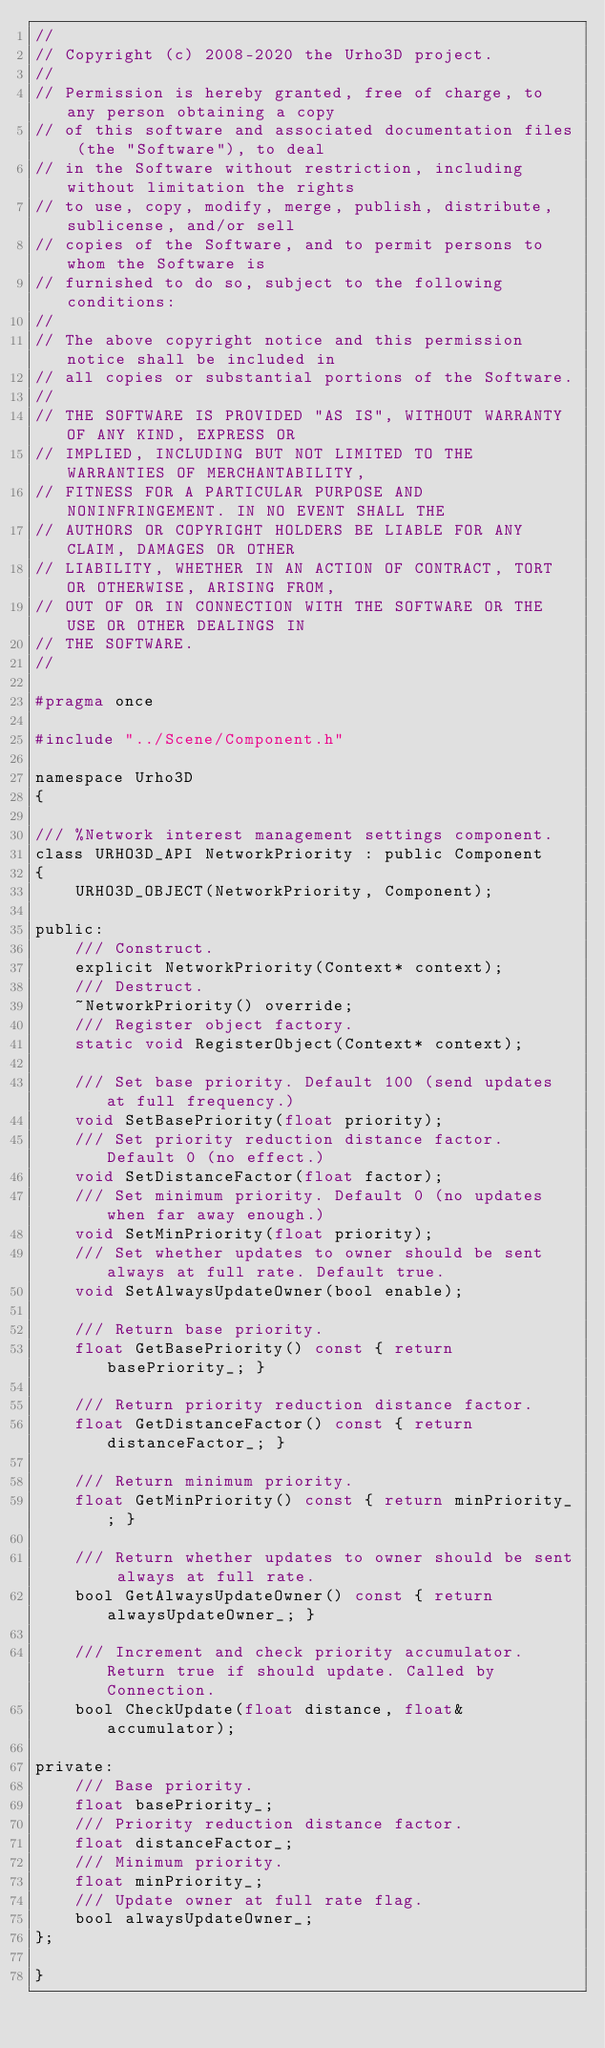<code> <loc_0><loc_0><loc_500><loc_500><_C_>//
// Copyright (c) 2008-2020 the Urho3D project.
//
// Permission is hereby granted, free of charge, to any person obtaining a copy
// of this software and associated documentation files (the "Software"), to deal
// in the Software without restriction, including without limitation the rights
// to use, copy, modify, merge, publish, distribute, sublicense, and/or sell
// copies of the Software, and to permit persons to whom the Software is
// furnished to do so, subject to the following conditions:
//
// The above copyright notice and this permission notice shall be included in
// all copies or substantial portions of the Software.
//
// THE SOFTWARE IS PROVIDED "AS IS", WITHOUT WARRANTY OF ANY KIND, EXPRESS OR
// IMPLIED, INCLUDING BUT NOT LIMITED TO THE WARRANTIES OF MERCHANTABILITY,
// FITNESS FOR A PARTICULAR PURPOSE AND NONINFRINGEMENT. IN NO EVENT SHALL THE
// AUTHORS OR COPYRIGHT HOLDERS BE LIABLE FOR ANY CLAIM, DAMAGES OR OTHER
// LIABILITY, WHETHER IN AN ACTION OF CONTRACT, TORT OR OTHERWISE, ARISING FROM,
// OUT OF OR IN CONNECTION WITH THE SOFTWARE OR THE USE OR OTHER DEALINGS IN
// THE SOFTWARE.
//

#pragma once

#include "../Scene/Component.h"

namespace Urho3D
{

/// %Network interest management settings component.
class URHO3D_API NetworkPriority : public Component
{
    URHO3D_OBJECT(NetworkPriority, Component);

public:
    /// Construct.
    explicit NetworkPriority(Context* context);
    /// Destruct.
    ~NetworkPriority() override;
    /// Register object factory.
    static void RegisterObject(Context* context);

    /// Set base priority. Default 100 (send updates at full frequency.)
    void SetBasePriority(float priority);
    /// Set priority reduction distance factor. Default 0 (no effect.)
    void SetDistanceFactor(float factor);
    /// Set minimum priority. Default 0 (no updates when far away enough.)
    void SetMinPriority(float priority);
    /// Set whether updates to owner should be sent always at full rate. Default true.
    void SetAlwaysUpdateOwner(bool enable);

    /// Return base priority.
    float GetBasePriority() const { return basePriority_; }

    /// Return priority reduction distance factor.
    float GetDistanceFactor() const { return distanceFactor_; }

    /// Return minimum priority.
    float GetMinPriority() const { return minPriority_; }

    /// Return whether updates to owner should be sent always at full rate.
    bool GetAlwaysUpdateOwner() const { return alwaysUpdateOwner_; }

    /// Increment and check priority accumulator. Return true if should update. Called by Connection.
    bool CheckUpdate(float distance, float& accumulator);

private:
    /// Base priority.
    float basePriority_;
    /// Priority reduction distance factor.
    float distanceFactor_;
    /// Minimum priority.
    float minPriority_;
    /// Update owner at full rate flag.
    bool alwaysUpdateOwner_;
};

}
</code> 